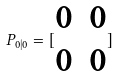<formula> <loc_0><loc_0><loc_500><loc_500>P _ { 0 | 0 } = [ \begin{matrix} 0 & 0 \\ 0 & 0 \end{matrix} ]</formula> 